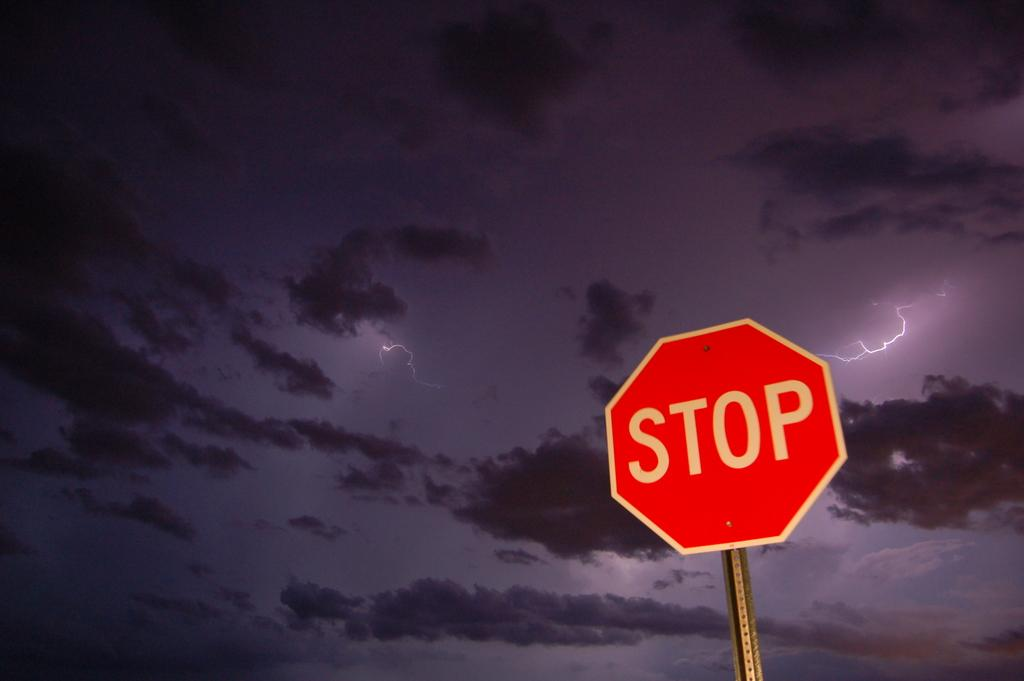Provide a one-sentence caption for the provided image. An dark clear sky with a few puffy clouds and a couple lighting bolts and also with a stop sign showing in the night sky. 